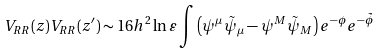Convert formula to latex. <formula><loc_0><loc_0><loc_500><loc_500>V _ { R R } ( z ) V _ { R R } ( z ^ { \prime } ) \sim 1 6 h ^ { 2 } \ln \varepsilon \int \left ( \psi ^ { \mu } \tilde { \psi } _ { \mu } - \psi ^ { M } \tilde { \psi } _ { M } \right ) e ^ { - \phi } e ^ { - \tilde { \phi } }</formula> 